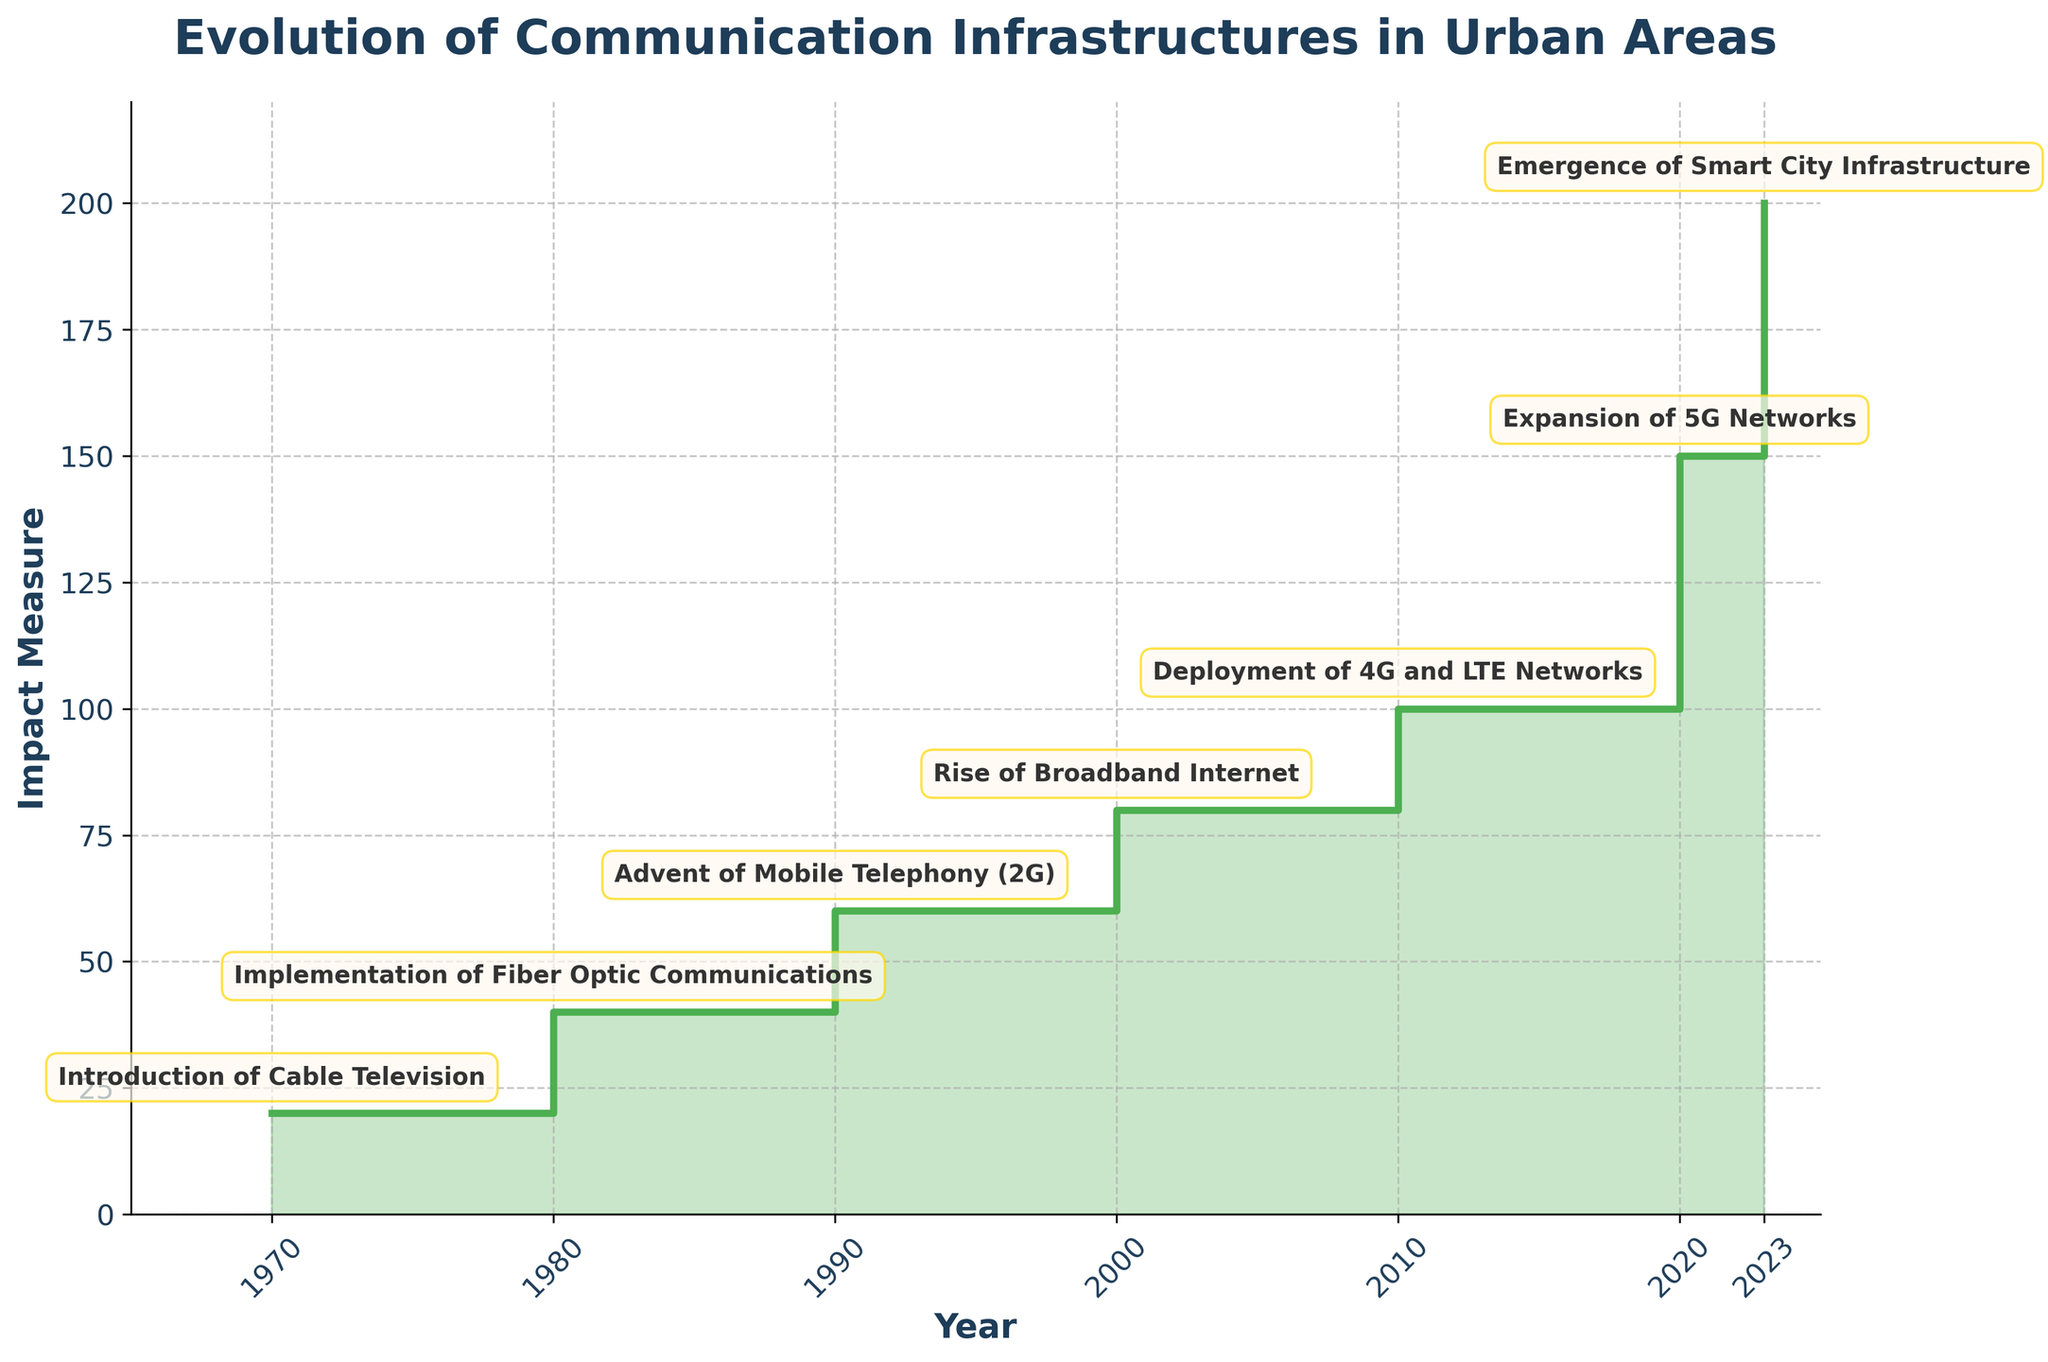What is the title of the chart? The title of the chart is always located at the top of the figure. By reading the text displayed at the top center, you can determine the chart’s title.
Answer: Evolution of Communication Infrastructures in Urban Areas Which year had the introduction of Cable Television, and what was its impact measure? Locate the annotation or label corresponding to the introduction of Cable Television and the year 1970. Follow the nearest point on the y-axis to determine the impact measure.
Answer: 1970, 20 What innovation happened in 2000, and what was its corresponding impact measure? Identify the annotation for the year 2000 on the x-axis. Read the label for the innovation and check the corresponding point on the y-axis to find the impact measure.
Answer: Rise of Broadband Internet, 80 Which innovation marked the highest impact measure according to the chart? Look for the highest point on the y-axis and check the label associated with it. Identify the corresponding innovation in the annotations.
Answer: Emergence of Smart City Infrastructure What is the range of years covered in the chart? Check the x-axis to find the starting and ending year values displayed. The range is from the first to the last year shown on the x-axis.
Answer: 1965 to 2025 How many key innovations are annotated in the figure? Count the number of distinct annotations or labels for each innovation mentioned along the plotted line in the figure.
Answer: 7 What was the impact measure when broadband internet rose? Look at the annotation for the year 2000 to see the associated innovation, "Rise of Broadband Internet." Then, check the corresponding plot point on the y-axis for its impact measure.
Answer: 80 What trend do you observe in the impact measures from 1970 to 2023? By analyzing the plotted points from the start year (1970) to the final visible year (2023), observe whether the impact measure continually increases, decreases, or has fluctuations. Summarize the general trend.
Answer: Continually increasing 